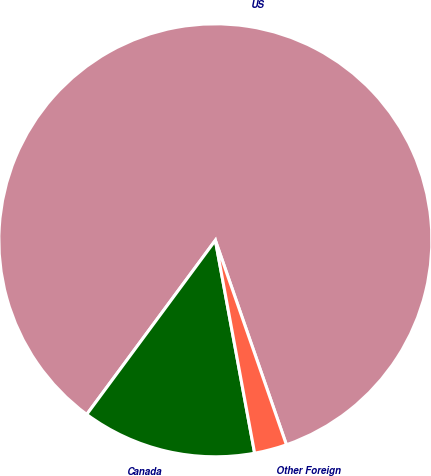Convert chart. <chart><loc_0><loc_0><loc_500><loc_500><pie_chart><fcel>US<fcel>Canada<fcel>Other Foreign<nl><fcel>84.55%<fcel>13.03%<fcel>2.42%<nl></chart> 